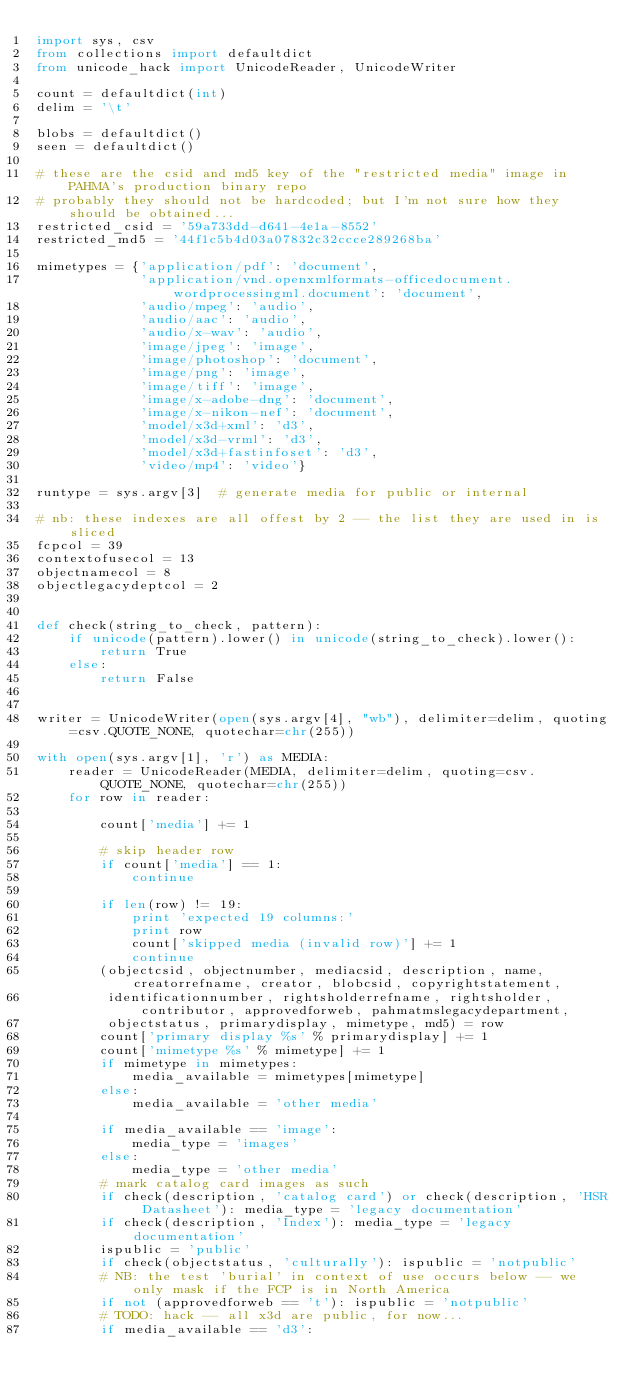Convert code to text. <code><loc_0><loc_0><loc_500><loc_500><_Python_>import sys, csv
from collections import defaultdict
from unicode_hack import UnicodeReader, UnicodeWriter

count = defaultdict(int)
delim = '\t'

blobs = defaultdict()
seen = defaultdict()

# these are the csid and md5 key of the "restricted media" image in PAHMA's production binary repo
# probably they should not be hardcoded; but I'm not sure how they should be obtained...
restricted_csid = '59a733dd-d641-4e1a-8552'
restricted_md5 = '44f1c5b4d03a07832c32ccce289268ba'

mimetypes = {'application/pdf': 'document',
             'application/vnd.openxmlformats-officedocument.wordprocessingml.document': 'document',
             'audio/mpeg': 'audio',
             'audio/aac': 'audio',
             'audio/x-wav': 'audio',
             'image/jpeg': 'image',
             'image/photoshop': 'document',
             'image/png': 'image',
             'image/tiff': 'image',
             'image/x-adobe-dng': 'document',
             'image/x-nikon-nef': 'document',
             'model/x3d+xml': 'd3',
             'model/x3d-vrml': 'd3',
             'model/x3d+fastinfoset': 'd3',
             'video/mp4': 'video'}

runtype = sys.argv[3]  # generate media for public or internal

# nb: these indexes are all offest by 2 -- the list they are used in is sliced
fcpcol = 39
contextofusecol = 13
objectnamecol = 8
objectlegacydeptcol = 2


def check(string_to_check, pattern):
    if unicode(pattern).lower() in unicode(string_to_check).lower():
        return True
    else:
        return False


writer = UnicodeWriter(open(sys.argv[4], "wb"), delimiter=delim, quoting=csv.QUOTE_NONE, quotechar=chr(255))

with open(sys.argv[1], 'r') as MEDIA:
    reader = UnicodeReader(MEDIA, delimiter=delim, quoting=csv.QUOTE_NONE, quotechar=chr(255))
    for row in reader:

        count['media'] += 1

        # skip header row
        if count['media'] == 1:
            continue

        if len(row) != 19:
            print 'expected 19 columns:'
            print row
            count['skipped media (invalid row)'] += 1
            continue
        (objectcsid, objectnumber, mediacsid, description, name, creatorrefname, creator, blobcsid, copyrightstatement,
         identificationnumber, rightsholderrefname, rightsholder, contributor, approvedforweb, pahmatmslegacydepartment,
         objectstatus, primarydisplay, mimetype, md5) = row
        count['primary display %s' % primarydisplay] += 1
        count['mimetype %s' % mimetype] += 1
        if mimetype in mimetypes:
            media_available = mimetypes[mimetype]
        else:
            media_available = 'other media'

        if media_available == 'image':
            media_type = 'images'
        else:
            media_type = 'other media'
        # mark catalog card images as such
        if check(description, 'catalog card') or check(description, 'HSR Datasheet'): media_type = 'legacy documentation'
        if check(description, 'Index'): media_type = 'legacy documentation'
        ispublic = 'public'
        if check(objectstatus, 'culturally'): ispublic = 'notpublic'
        # NB: the test 'burial' in context of use occurs below -- we only mask if the FCP is in North America
        if not (approvedforweb == 't'): ispublic = 'notpublic'
        # TODO: hack -- all x3d are public, for now...
        if media_available == 'd3':</code> 